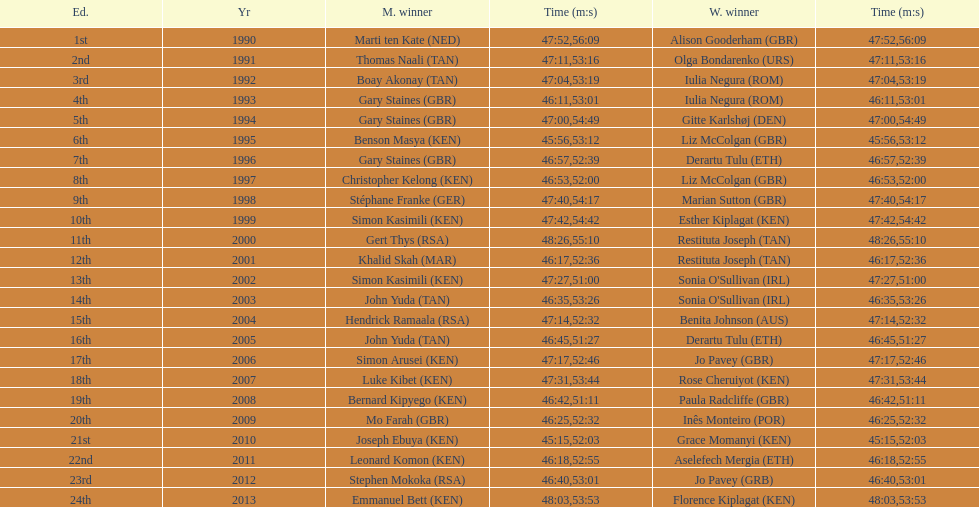What is the number of times, between 1990 and 2013, for britain not to win the men's or women's bupa great south run? 13. 